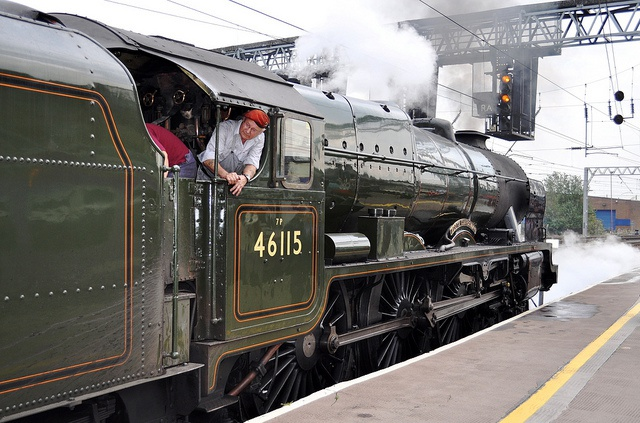Describe the objects in this image and their specific colors. I can see train in darkgray, black, and gray tones, people in darkgray, gray, black, and lightgray tones, people in darkgray, brown, maroon, and purple tones, and traffic light in darkgray, black, gray, and lightgray tones in this image. 